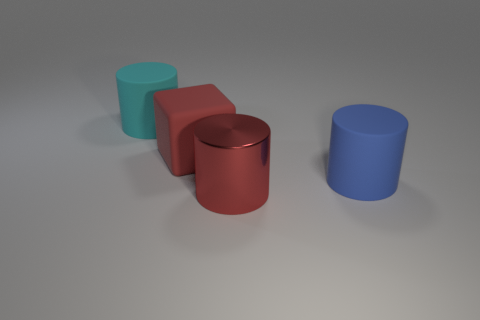Is there anything else that is made of the same material as the big red cylinder?
Your response must be concise. No. Is the rubber block the same color as the shiny cylinder?
Your response must be concise. Yes. What number of cylinders are rubber things or red rubber things?
Provide a succinct answer. 2. What is the shape of the matte object that is in front of the red matte block?
Offer a terse response. Cylinder. What number of cylinders are made of the same material as the blue thing?
Provide a succinct answer. 1. Is the number of blue things that are to the right of the large blue cylinder less than the number of cyan matte objects?
Give a very brief answer. Yes. What is the size of the matte cylinder in front of the cylinder behind the matte block?
Provide a short and direct response. Large. Is the color of the big rubber block the same as the matte object that is behind the big red cube?
Offer a very short reply. No. What material is the other red thing that is the same size as the red matte thing?
Give a very brief answer. Metal. Are there fewer large matte things that are in front of the big red matte cube than red things in front of the cyan rubber cylinder?
Give a very brief answer. Yes. 